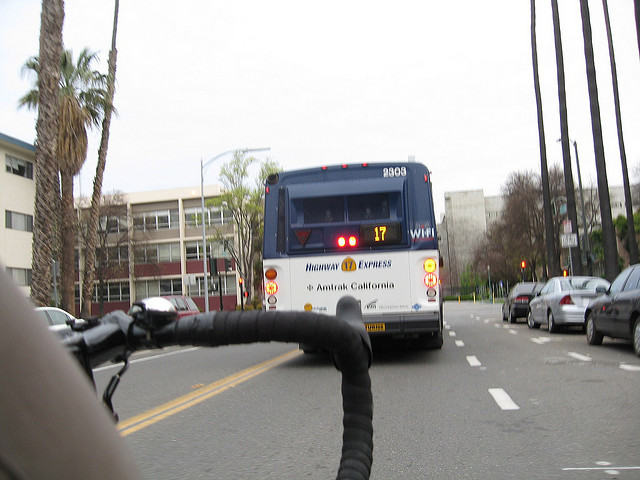<image>What company owns the black truck? There is no black truck in the image. However, if there was, the company ownership isn't visible. What company owns the black truck? There is no black truck in the image. 